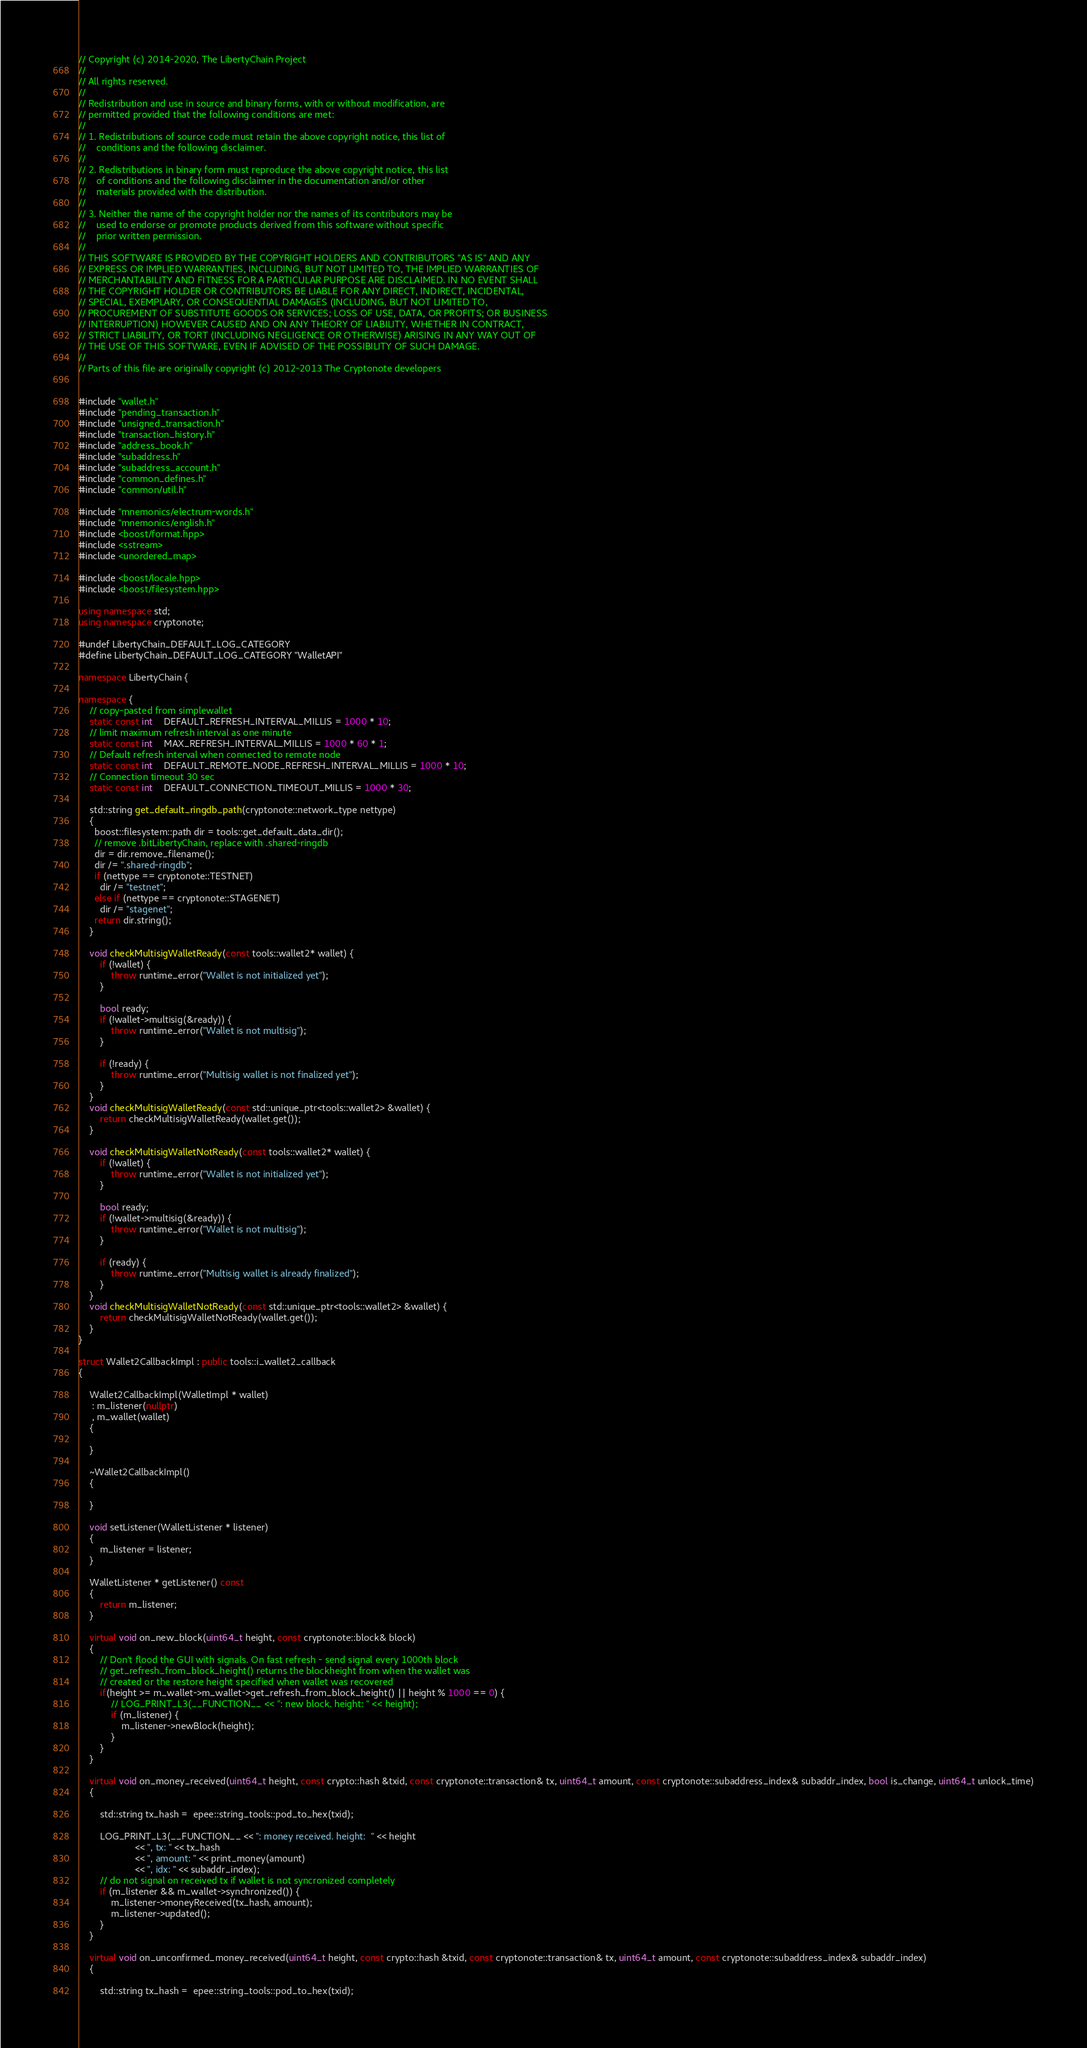<code> <loc_0><loc_0><loc_500><loc_500><_C++_>// Copyright (c) 2014-2020, The LibertyChain Project
//
// All rights reserved.
//
// Redistribution and use in source and binary forms, with or without modification, are
// permitted provided that the following conditions are met:
//
// 1. Redistributions of source code must retain the above copyright notice, this list of
//    conditions and the following disclaimer.
//
// 2. Redistributions in binary form must reproduce the above copyright notice, this list
//    of conditions and the following disclaimer in the documentation and/or other
//    materials provided with the distribution.
//
// 3. Neither the name of the copyright holder nor the names of its contributors may be
//    used to endorse or promote products derived from this software without specific
//    prior written permission.
//
// THIS SOFTWARE IS PROVIDED BY THE COPYRIGHT HOLDERS AND CONTRIBUTORS "AS IS" AND ANY
// EXPRESS OR IMPLIED WARRANTIES, INCLUDING, BUT NOT LIMITED TO, THE IMPLIED WARRANTIES OF
// MERCHANTABILITY AND FITNESS FOR A PARTICULAR PURPOSE ARE DISCLAIMED. IN NO EVENT SHALL
// THE COPYRIGHT HOLDER OR CONTRIBUTORS BE LIABLE FOR ANY DIRECT, INDIRECT, INCIDENTAL,
// SPECIAL, EXEMPLARY, OR CONSEQUENTIAL DAMAGES (INCLUDING, BUT NOT LIMITED TO,
// PROCUREMENT OF SUBSTITUTE GOODS OR SERVICES; LOSS OF USE, DATA, OR PROFITS; OR BUSINESS
// INTERRUPTION) HOWEVER CAUSED AND ON ANY THEORY OF LIABILITY, WHETHER IN CONTRACT,
// STRICT LIABILITY, OR TORT (INCLUDING NEGLIGENCE OR OTHERWISE) ARISING IN ANY WAY OUT OF
// THE USE OF THIS SOFTWARE, EVEN IF ADVISED OF THE POSSIBILITY OF SUCH DAMAGE.
//
// Parts of this file are originally copyright (c) 2012-2013 The Cryptonote developers


#include "wallet.h"
#include "pending_transaction.h"
#include "unsigned_transaction.h"
#include "transaction_history.h"
#include "address_book.h"
#include "subaddress.h"
#include "subaddress_account.h"
#include "common_defines.h"
#include "common/util.h"

#include "mnemonics/electrum-words.h"
#include "mnemonics/english.h"
#include <boost/format.hpp>
#include <sstream>
#include <unordered_map>

#include <boost/locale.hpp>
#include <boost/filesystem.hpp>

using namespace std;
using namespace cryptonote;

#undef LibertyChain_DEFAULT_LOG_CATEGORY
#define LibertyChain_DEFAULT_LOG_CATEGORY "WalletAPI"

namespace LibertyChain {

namespace {
    // copy-pasted from simplewallet
    static const int    DEFAULT_REFRESH_INTERVAL_MILLIS = 1000 * 10;
    // limit maximum refresh interval as one minute
    static const int    MAX_REFRESH_INTERVAL_MILLIS = 1000 * 60 * 1;
    // Default refresh interval when connected to remote node
    static const int    DEFAULT_REMOTE_NODE_REFRESH_INTERVAL_MILLIS = 1000 * 10;
    // Connection timeout 30 sec
    static const int    DEFAULT_CONNECTION_TIMEOUT_MILLIS = 1000 * 30;

    std::string get_default_ringdb_path(cryptonote::network_type nettype)
    {
      boost::filesystem::path dir = tools::get_default_data_dir();
      // remove .bitLibertyChain, replace with .shared-ringdb
      dir = dir.remove_filename();
      dir /= ".shared-ringdb";
      if (nettype == cryptonote::TESTNET)
        dir /= "testnet";
      else if (nettype == cryptonote::STAGENET)
        dir /= "stagenet";
      return dir.string();
    }

    void checkMultisigWalletReady(const tools::wallet2* wallet) {
        if (!wallet) {
            throw runtime_error("Wallet is not initialized yet");
        }

        bool ready;
        if (!wallet->multisig(&ready)) {
            throw runtime_error("Wallet is not multisig");
        }

        if (!ready) {
            throw runtime_error("Multisig wallet is not finalized yet");
        }
    }
    void checkMultisigWalletReady(const std::unique_ptr<tools::wallet2> &wallet) {
        return checkMultisigWalletReady(wallet.get());
    }

    void checkMultisigWalletNotReady(const tools::wallet2* wallet) {
        if (!wallet) {
            throw runtime_error("Wallet is not initialized yet");
        }

        bool ready;
        if (!wallet->multisig(&ready)) {
            throw runtime_error("Wallet is not multisig");
        }

        if (ready) {
            throw runtime_error("Multisig wallet is already finalized");
        }
    }
    void checkMultisigWalletNotReady(const std::unique_ptr<tools::wallet2> &wallet) {
        return checkMultisigWalletNotReady(wallet.get());
    }
}

struct Wallet2CallbackImpl : public tools::i_wallet2_callback
{

    Wallet2CallbackImpl(WalletImpl * wallet)
     : m_listener(nullptr)
     , m_wallet(wallet)
    {

    }

    ~Wallet2CallbackImpl()
    {

    }

    void setListener(WalletListener * listener)
    {
        m_listener = listener;
    }

    WalletListener * getListener() const
    {
        return m_listener;
    }

    virtual void on_new_block(uint64_t height, const cryptonote::block& block)
    {
        // Don't flood the GUI with signals. On fast refresh - send signal every 1000th block
        // get_refresh_from_block_height() returns the blockheight from when the wallet was 
        // created or the restore height specified when wallet was recovered
        if(height >= m_wallet->m_wallet->get_refresh_from_block_height() || height % 1000 == 0) {
            // LOG_PRINT_L3(__FUNCTION__ << ": new block. height: " << height);
            if (m_listener) {
                m_listener->newBlock(height);
            }
        }
    }

    virtual void on_money_received(uint64_t height, const crypto::hash &txid, const cryptonote::transaction& tx, uint64_t amount, const cryptonote::subaddress_index& subaddr_index, bool is_change, uint64_t unlock_time)
    {

        std::string tx_hash =  epee::string_tools::pod_to_hex(txid);

        LOG_PRINT_L3(__FUNCTION__ << ": money received. height:  " << height
                     << ", tx: " << tx_hash
                     << ", amount: " << print_money(amount)
                     << ", idx: " << subaddr_index);
        // do not signal on received tx if wallet is not syncronized completely
        if (m_listener && m_wallet->synchronized()) {
            m_listener->moneyReceived(tx_hash, amount);
            m_listener->updated();
        }
    }

    virtual void on_unconfirmed_money_received(uint64_t height, const crypto::hash &txid, const cryptonote::transaction& tx, uint64_t amount, const cryptonote::subaddress_index& subaddr_index)
    {

        std::string tx_hash =  epee::string_tools::pod_to_hex(txid);
</code> 